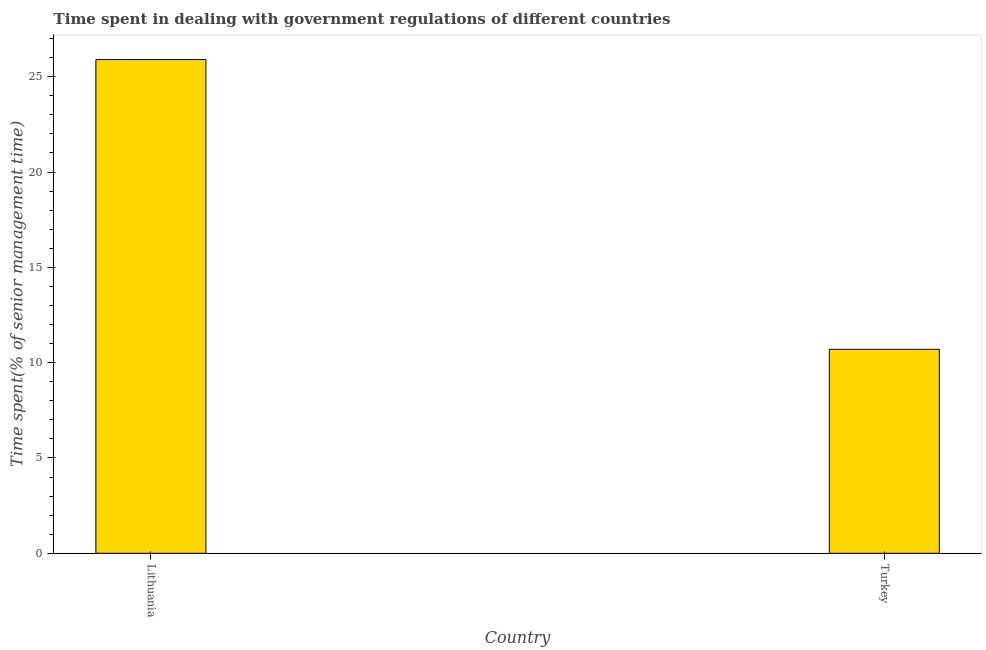Does the graph contain grids?
Keep it short and to the point. No. What is the title of the graph?
Your answer should be compact. Time spent in dealing with government regulations of different countries. What is the label or title of the Y-axis?
Your answer should be very brief. Time spent(% of senior management time). What is the time spent in dealing with government regulations in Lithuania?
Provide a short and direct response. 25.9. Across all countries, what is the maximum time spent in dealing with government regulations?
Offer a terse response. 25.9. In which country was the time spent in dealing with government regulations maximum?
Your answer should be compact. Lithuania. What is the sum of the time spent in dealing with government regulations?
Your answer should be compact. 36.6. What is the difference between the time spent in dealing with government regulations in Lithuania and Turkey?
Give a very brief answer. 15.2. What is the median time spent in dealing with government regulations?
Your answer should be very brief. 18.3. What is the ratio of the time spent in dealing with government regulations in Lithuania to that in Turkey?
Ensure brevity in your answer.  2.42. In how many countries, is the time spent in dealing with government regulations greater than the average time spent in dealing with government regulations taken over all countries?
Offer a very short reply. 1. How many bars are there?
Your answer should be compact. 2. Are the values on the major ticks of Y-axis written in scientific E-notation?
Keep it short and to the point. No. What is the Time spent(% of senior management time) of Lithuania?
Keep it short and to the point. 25.9. What is the ratio of the Time spent(% of senior management time) in Lithuania to that in Turkey?
Keep it short and to the point. 2.42. 